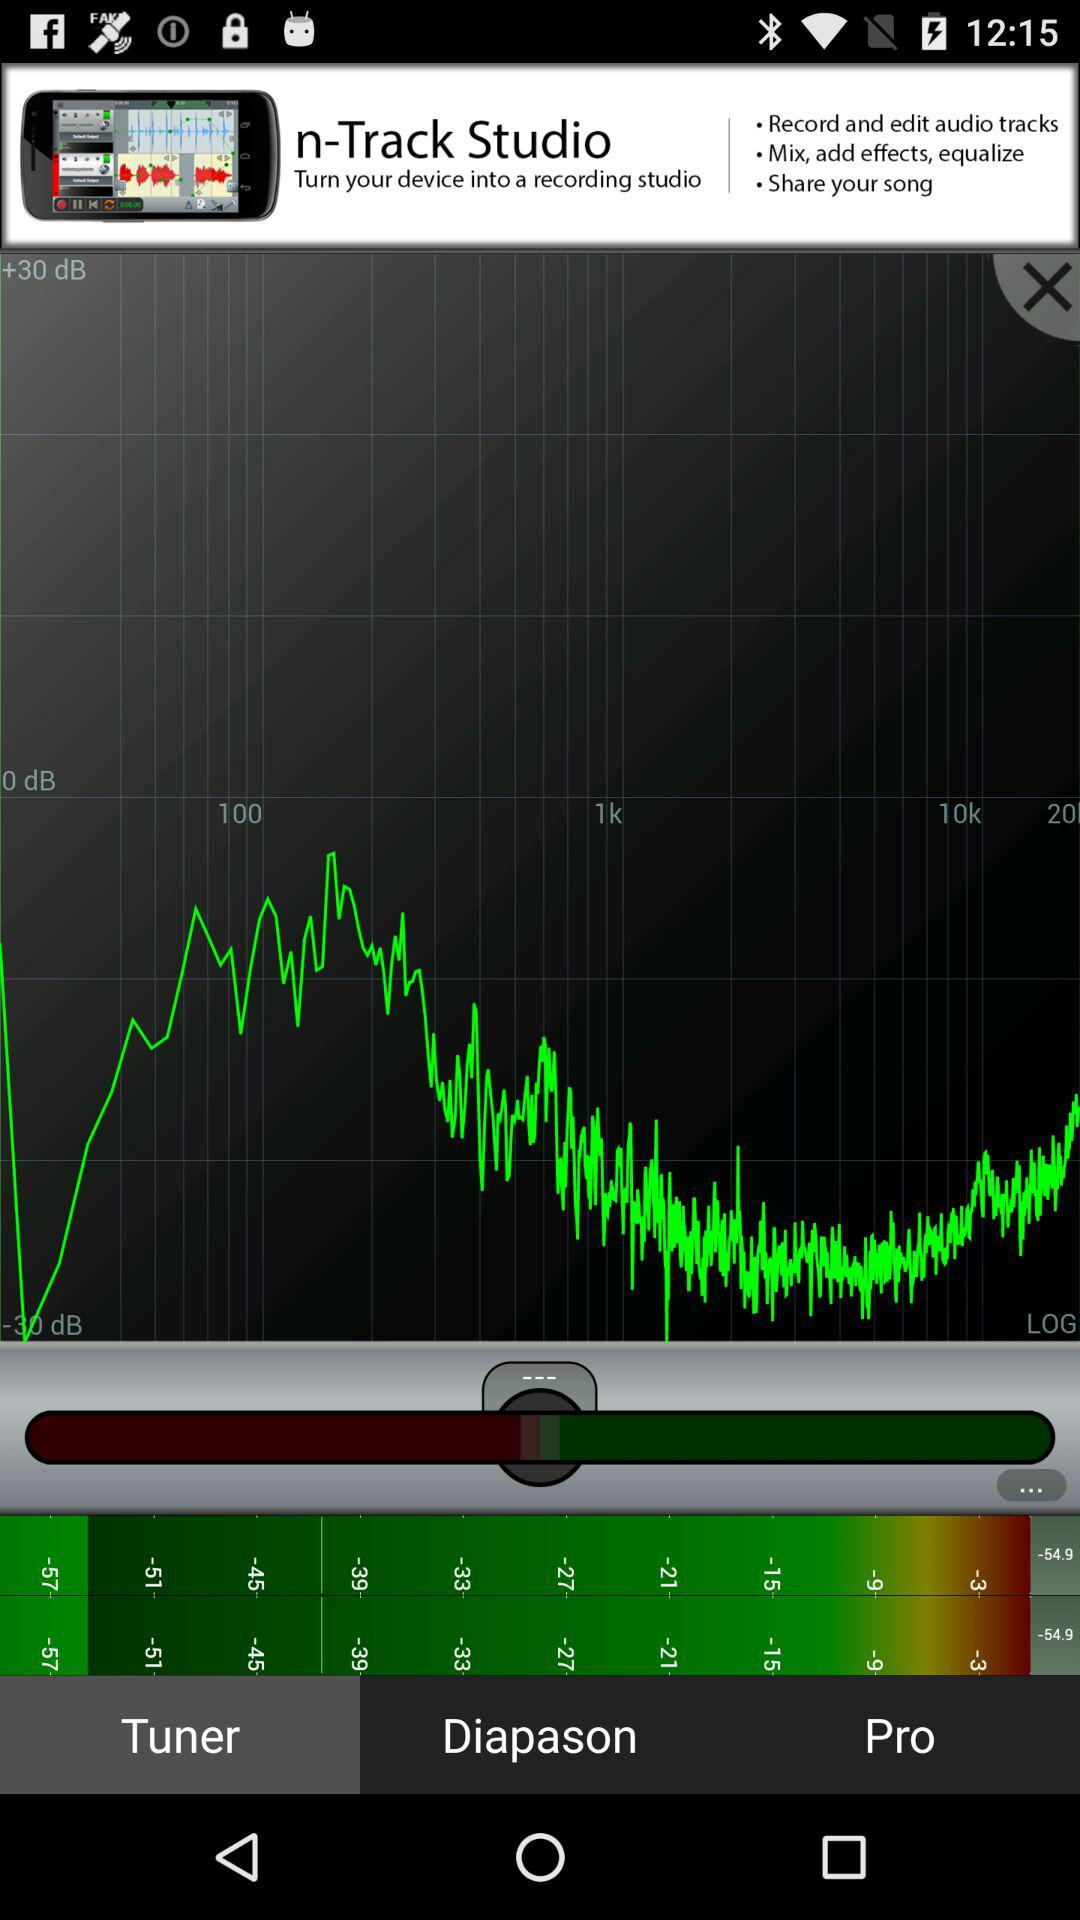Which tab is selected? The selected tab is "Tuner". 